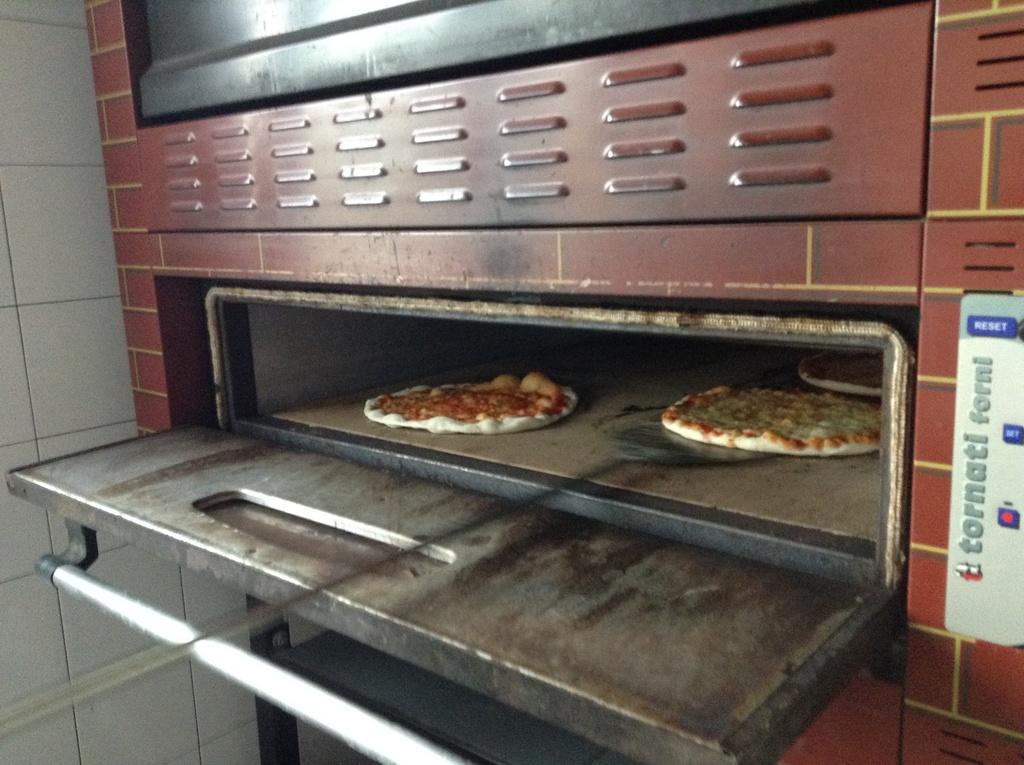What kind of oven is being used?
Provide a succinct answer. Tornati forni. What does the sign say at the very top next to the opening?
Keep it short and to the point. Reset. 